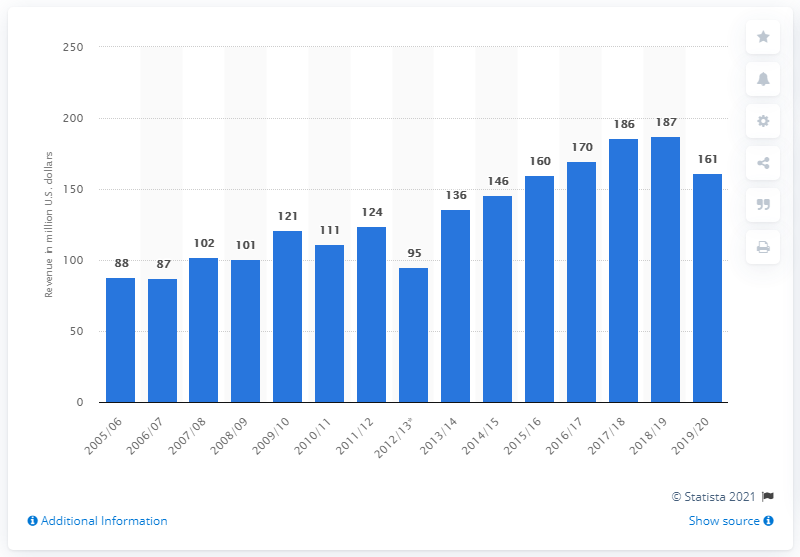List a handful of essential elements in this visual. In the 2019/2020 season, the Philadelphia Flyers generated a total revenue of 161 million dollars. 